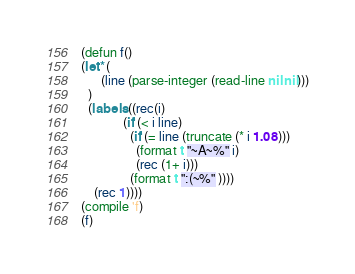<code> <loc_0><loc_0><loc_500><loc_500><_Lisp_>(defun f()
(let* (
      (line (parse-integer (read-line nil nil)))
  )
  (labels ((rec(i)
             (if (< i line)
               (if (= line (truncate (* i 1.08)))
                 (format t "~A~%" i)
                 (rec (1+ i)))
               (format t ":(~%" ))))
    (rec 1))))
(compile 'f)
(f)
</code> 